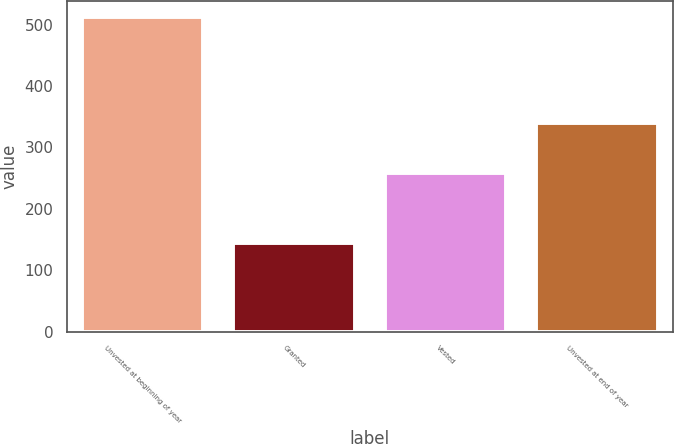Convert chart to OTSL. <chart><loc_0><loc_0><loc_500><loc_500><bar_chart><fcel>Unvested at beginning of year<fcel>Granted<fcel>Vested<fcel>Unvested at end of year<nl><fcel>513<fcel>145<fcel>259<fcel>339<nl></chart> 